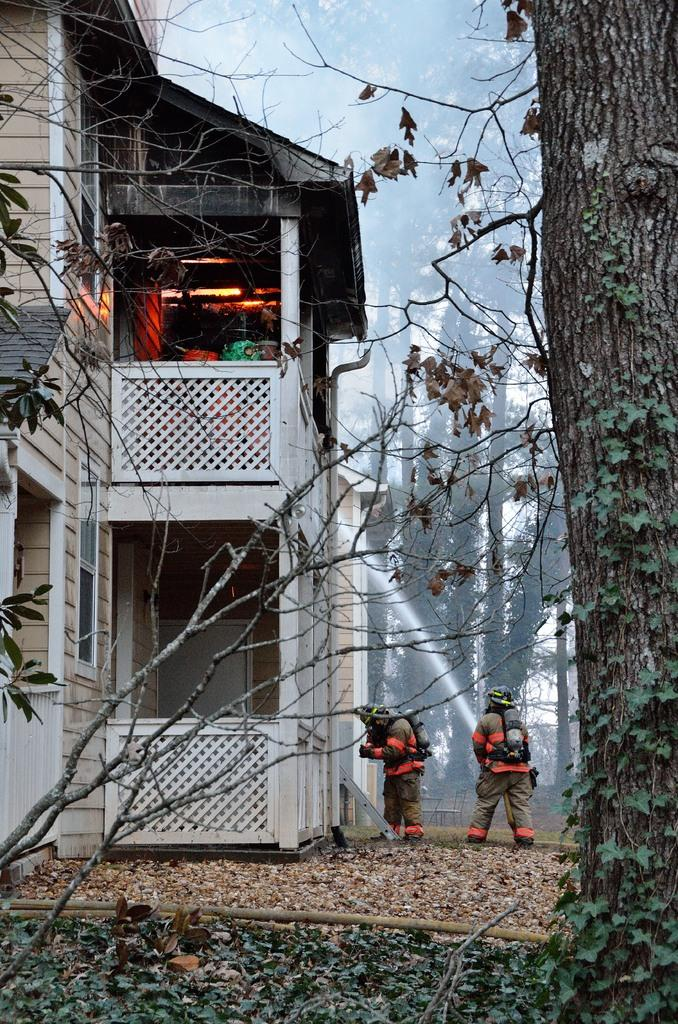What structure is visible in the image? There is a building in the image. Are there any people in the image? Yes, two persons are standing near the building on the ground. What type of vegetation can be seen in the image? There are trees in the image. Can you describe any specific details about the trees? There is a creeper plant on one of the trees. Where is the faucet located in the image? There is no faucet present in the image. Can you tell me how many mines are visible in the image? There are no mines present in the image. 